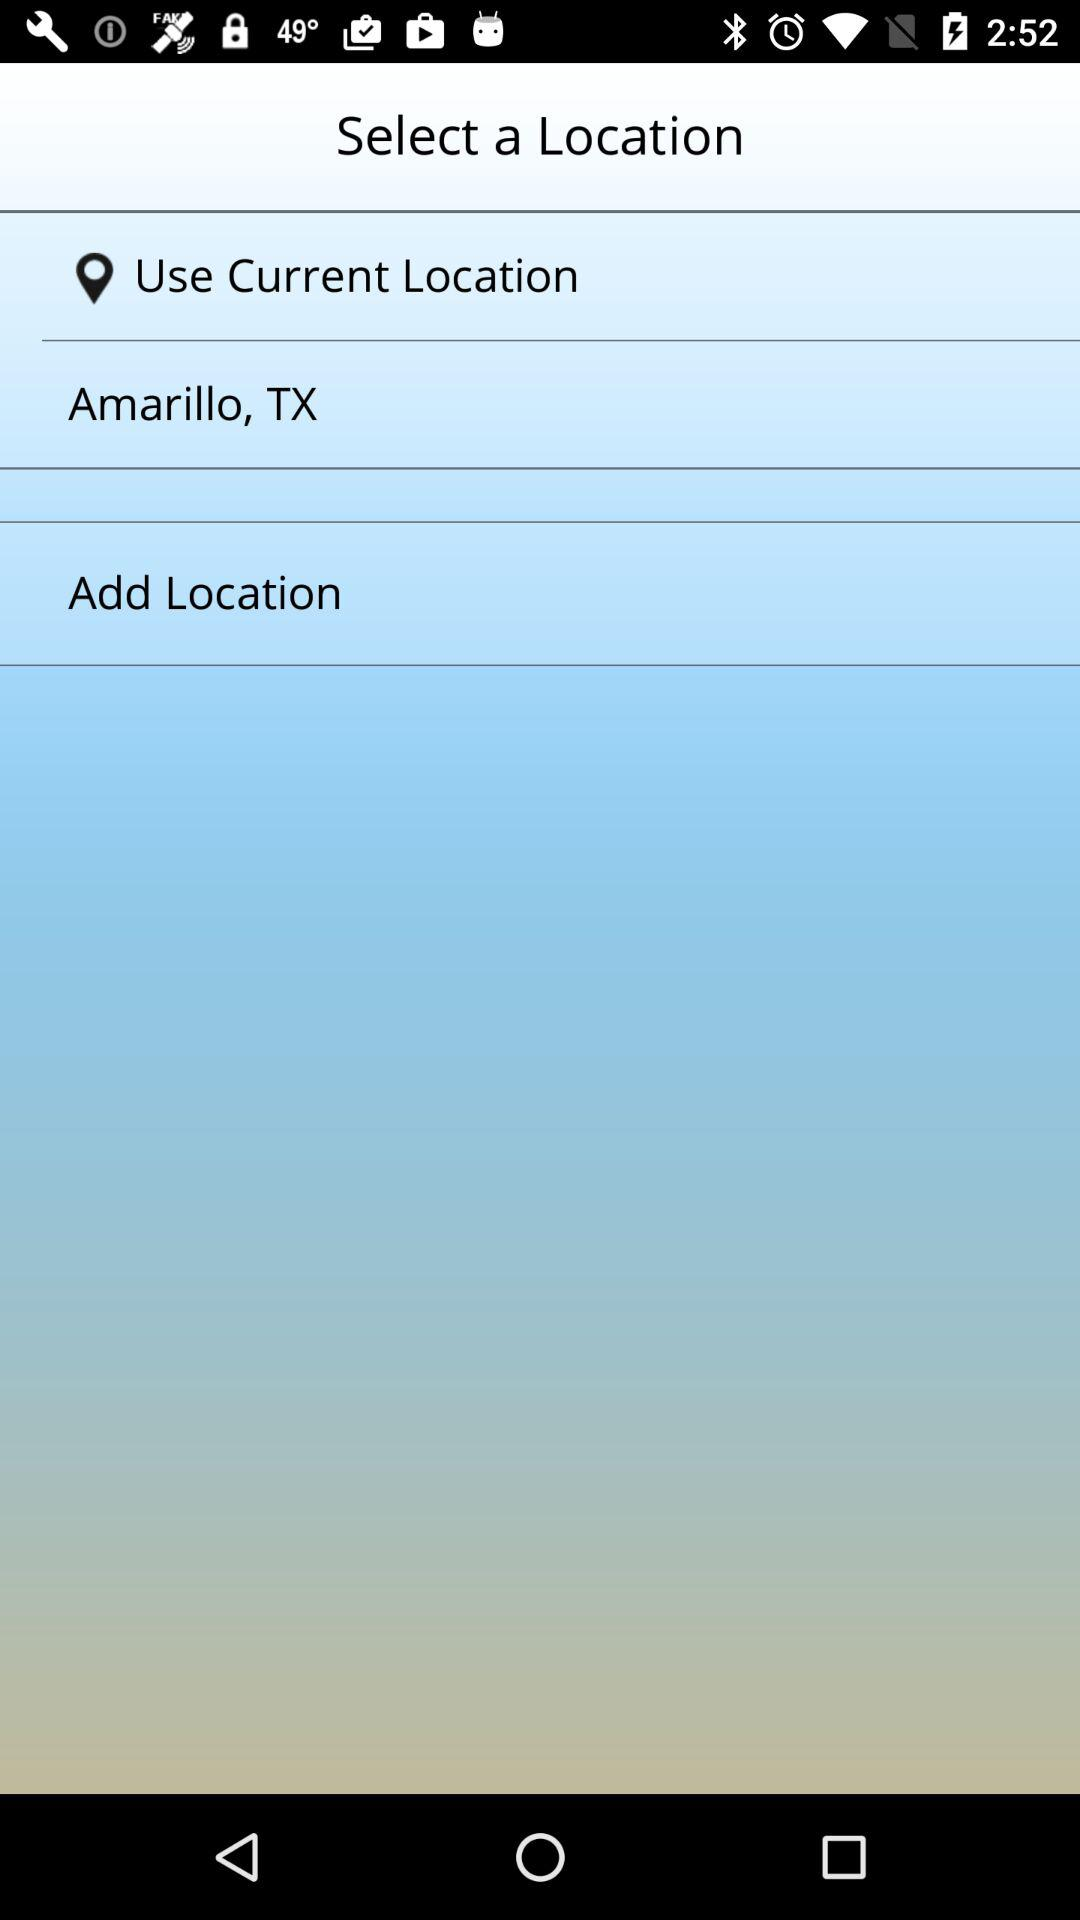What are the options for selecting a location? The options for selecting a location are "Use Current Location" and "Amarillo, TX". 